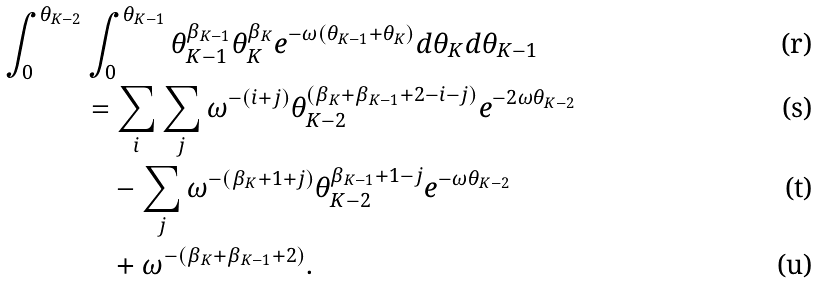Convert formula to latex. <formula><loc_0><loc_0><loc_500><loc_500>\int _ { 0 } ^ { \theta _ { K - 2 } } & \int _ { 0 } ^ { \theta _ { K - 1 } } \theta _ { K - 1 } ^ { \beta _ { K - 1 } } \theta _ { K } ^ { \beta _ { K } } e ^ { - \omega ( \theta _ { K - 1 } + \theta _ { K } ) } d \theta _ { K } d \theta _ { K - 1 } \\ & = \sum _ { i } \sum _ { j } \omega ^ { - ( i + j ) } \theta _ { K - 2 } ^ { ( \beta _ { K } + \beta _ { K - 1 } + 2 - i - j ) } e ^ { - 2 \omega \theta _ { K - 2 } } \\ & \quad - \sum _ { j } \omega ^ { - ( \beta _ { K } + 1 + j ) } \theta _ { K - 2 } ^ { \beta _ { K - 1 } + 1 - j } e ^ { - \omega \theta _ { K - 2 } } \\ & \quad + \omega ^ { - ( \beta _ { K } + \beta _ { K - 1 } + 2 ) } .</formula> 